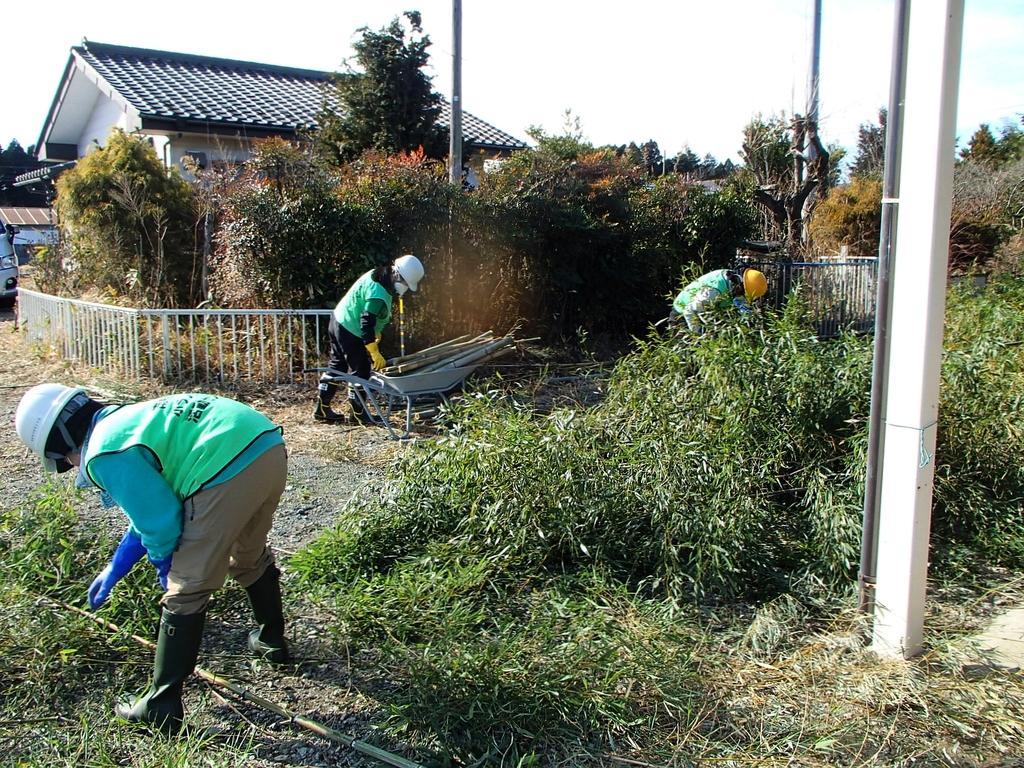Describe this image in one or two sentences. In the image there are plants and on the ground there is grass. There are three men with helmets on their heads. And also there is a stroller with some items in it. Behind them there is fencing. Behind the fencing there are trees. And also there is a house with roofs and walls. And also there are poles in the image. On the left corner of the image there is a vehicle. 